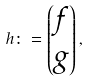<formula> <loc_0><loc_0><loc_500><loc_500>h \colon = \begin{pmatrix} f \\ g \end{pmatrix} ,</formula> 